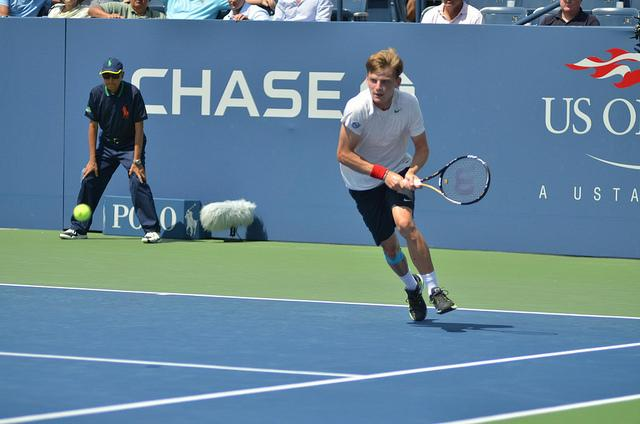What is he doing? Please explain your reasoning. chasing ball. A young boy is playing a tennis match. he is trying to hit the ball before it hits ground again. 